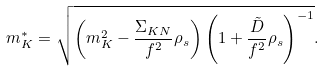Convert formula to latex. <formula><loc_0><loc_0><loc_500><loc_500>m _ { K } ^ { * } = \sqrt { \left ( m _ { K } ^ { 2 } - \frac { \Sigma _ { K N } } { f ^ { 2 } } \rho _ { s } \right ) \left ( 1 + \frac { \tilde { D } } { f ^ { 2 } } \rho _ { s } \right ) ^ { - 1 } } .</formula> 